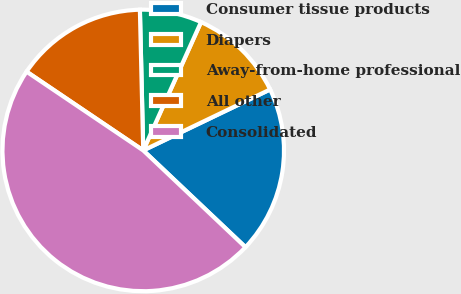Convert chart. <chart><loc_0><loc_0><loc_500><loc_500><pie_chart><fcel>Consumer tissue products<fcel>Diapers<fcel>Away-from-home professional<fcel>All other<fcel>Consolidated<nl><fcel>19.19%<fcel>11.14%<fcel>7.11%<fcel>15.17%<fcel>47.39%<nl></chart> 